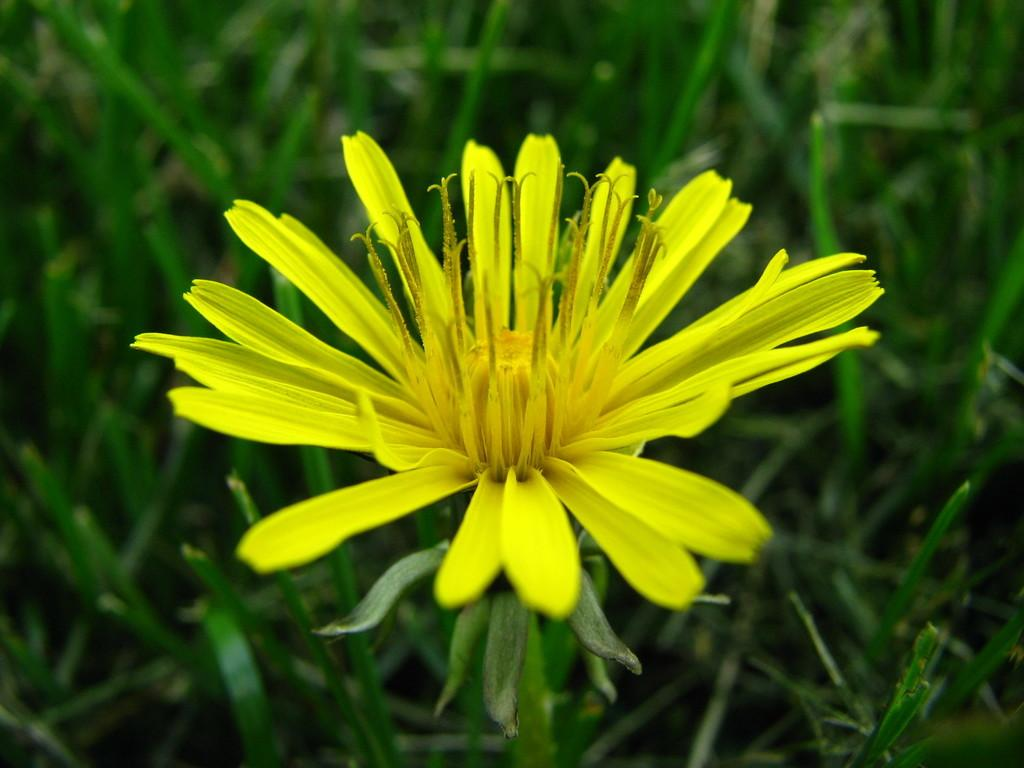What is the main subject of the image? There is a plant in the image. What color is the flower on the plant? The plant has a yellow flower. What can be seen in the background of the image? There are other plants in the background. What color are the leaves of the background plants? The background plants have green leaves. How does the grandmother use the heat in the cellar to help the plant grow in the image? There is no mention of a grandmother or a cellar in the image, and the plant's growth is not related to heat. 